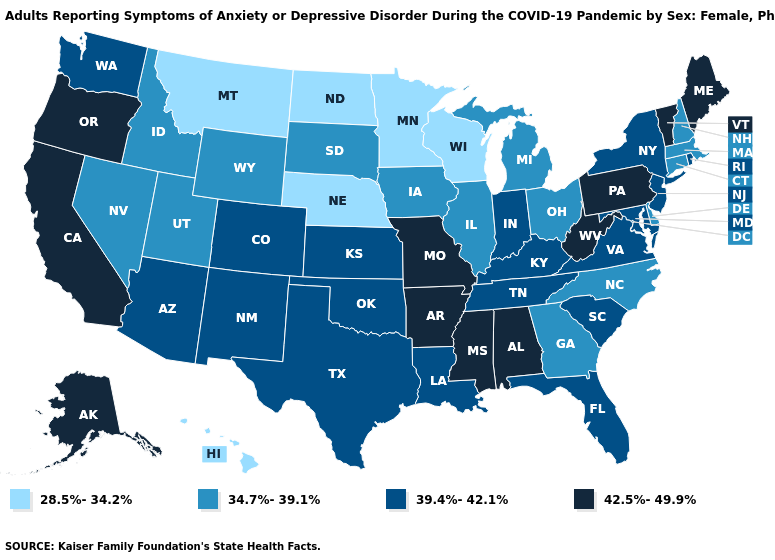Name the states that have a value in the range 39.4%-42.1%?
Concise answer only. Arizona, Colorado, Florida, Indiana, Kansas, Kentucky, Louisiana, Maryland, New Jersey, New Mexico, New York, Oklahoma, Rhode Island, South Carolina, Tennessee, Texas, Virginia, Washington. What is the value of Maine?
Concise answer only. 42.5%-49.9%. What is the lowest value in the West?
Concise answer only. 28.5%-34.2%. How many symbols are there in the legend?
Concise answer only. 4. What is the highest value in the USA?
Concise answer only. 42.5%-49.9%. What is the lowest value in states that border Iowa?
Write a very short answer. 28.5%-34.2%. Which states have the lowest value in the Northeast?
Quick response, please. Connecticut, Massachusetts, New Hampshire. Does the map have missing data?
Answer briefly. No. What is the highest value in the USA?
Concise answer only. 42.5%-49.9%. What is the value of Kansas?
Short answer required. 39.4%-42.1%. Name the states that have a value in the range 39.4%-42.1%?
Keep it brief. Arizona, Colorado, Florida, Indiana, Kansas, Kentucky, Louisiana, Maryland, New Jersey, New Mexico, New York, Oklahoma, Rhode Island, South Carolina, Tennessee, Texas, Virginia, Washington. Does New York have the same value as Maryland?
Be succinct. Yes. How many symbols are there in the legend?
Answer briefly. 4. How many symbols are there in the legend?
Concise answer only. 4. Which states hav the highest value in the West?
Be succinct. Alaska, California, Oregon. 